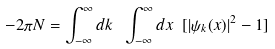Convert formula to latex. <formula><loc_0><loc_0><loc_500><loc_500>- 2 \pi N = \int _ { - \infty } ^ { \infty } d k \ \int _ { - \infty } ^ { \infty } d x \ [ | \psi _ { k } ( x ) | ^ { 2 } - 1 ]</formula> 